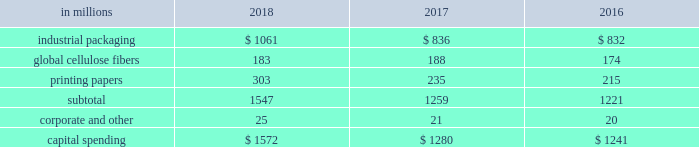The company recorded equity earnings , net of taxes , related to ilim of $ 290 million in 2018 , compared with earnings of $ 183 million in 2017 , and $ 199 million in 2016 .
Operating results recorded in 2018 included an after-tax non-cash foreign exchange loss of $ 82 million , compared with an after-tax foreign exchange gain of $ 15 million in 2017 and an after-tax foreign exchange gain of $ 25 million in 2016 , primarily on the remeasurement of ilim's u.s .
Dollar denominated net debt .
Ilim delivered outstanding performance in 2018 , driven largely by higher price realization and strong demand .
Sales volumes for the joint venture increased year over year for shipments to china of softwood pulp and linerboard , but were offset by decreased sales of hardwood pulp to china .
Sales volumes in the russian market increased for softwood pulp and hardwood pulp , but decreased for linerboard .
Average sales price realizations were significantly higher in 2018 for sales of softwood pulp , hardwood pulp and linerboard to china and other export markets .
Average sales price realizations in russian markets increased year over year for all products .
Input costs were higher in 2018 , primarily for wood , fuel and chemicals .
Distribution costs were negatively impacted by tariffs and inflation .
The company received cash dividends from the joint venture of $ 128 million in 2018 , $ 133 million in 2017 and $ 58 million in entering the first quarter of 2019 , sales volumes are expected to be lower than in the fourth quarter of 2018 , due to the seasonal slowdown in china and fewer trading days .
Based on pricing to date in the current quarter , average sales prices are expected to decrease for hardwood pulp , softwood pulp and linerboard to china .
Input costs are projected to be relatively flat , while distribution costs are expected to increase .
Equity earnings - gpip international paper recorded equity earnings of $ 46 million on its 20.5% ( 20.5 % ) ownership position in gpip in 2018 .
The company received cash dividends from the investment of $ 25 million in 2018 .
Liquidity and capital resources overview a major factor in international paper 2019s liquidity and capital resource planning is its generation of operating cash flow , which is highly sensitive to changes in the pricing and demand for our major products .
While changes in key cash operating costs , such as energy , raw material , mill outage and transportation costs , do have an effect on operating cash generation , we believe that our focus on pricing and cost controls has improved our cash flow generation over an operating cycle .
Cash uses during 2018 were primarily focused on working capital requirements , capital spending , debt reductions and returning cash to shareholders through dividends and share repurchases under the company's share repurchase program .
Cash provided by operating activities cash provided by operations , including discontinued operations , totaled $ 3.2 billion in 2018 , compared with $ 1.8 billion for 2017 , and $ 2.5 billion for 2016 .
Cash used by working capital components ( accounts receivable , contract assets and inventory less accounts payable and accrued liabilities , interest payable and other ) totaled $ 439 million in 2018 , compared with cash used by working capital components of $ 402 million in 2017 , and cash provided by working capital components of $ 71 million in 2016 .
Investment activities including discontinued operations , investment activities in 2018 increased from 2017 , as 2018 included higher capital spending .
In 2016 , investment activity included the purchase of weyerhaeuser's pulp business for $ 2.2 billion in cash , the purchase of the holmen business for $ 57 million in cash , net of cash acquired , and proceeds from the sale of the asia packaging business of $ 108 million , net of cash divested .
The company maintains an average capital spending target around depreciation and amortization levels , or modestly above , due to strategic plans over the course of an economic cycle .
Capital spending was $ 1.6 billion in 2018 , or 118% ( 118 % ) of depreciation and amortization , compared with $ 1.4 billion in 2017 , or 98% ( 98 % ) of depreciation and amortization , and $ 1.3 billion , or 110% ( 110 % ) of depreciation and amortization in 2016 .
Across our segments , capital spending as a percentage of depreciation and amortization ranged from 69.8% ( 69.8 % ) to 132.1% ( 132.1 % ) in 2018 .
The table shows capital spending for operations by business segment for the years ended december 31 , 2018 , 2017 and 2016 , excluding amounts related to discontinued operations of $ 111 million in 2017 and $ 107 million in 2016. .
Capital expenditures in 2019 are currently expected to be about $ 1.4 billion , or 104% ( 104 % ) of depreciation and amortization , including approximately $ 400 million of strategic investments. .
What is the average capital spending for the global cellulose fibers segment , considering the years 2016-2018? 
Rationale: it is the sum of all values divided by three .
Computations: table_average(global cellulose fibers, none)
Answer: 181.66667. 